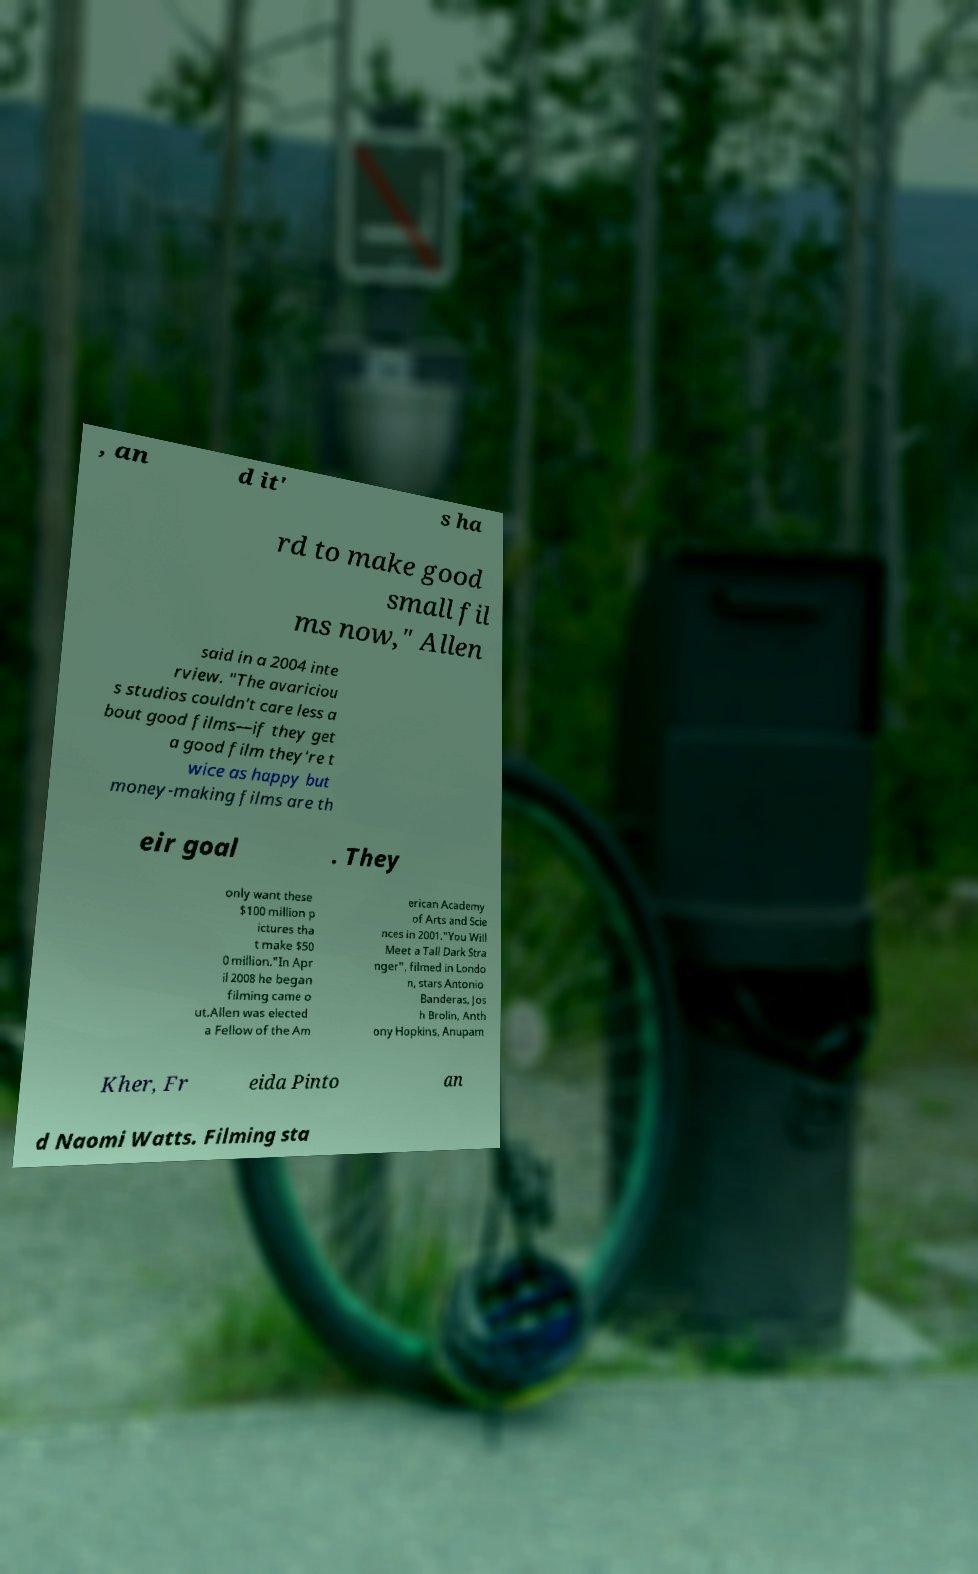Could you assist in decoding the text presented in this image and type it out clearly? , an d it' s ha rd to make good small fil ms now," Allen said in a 2004 inte rview. "The avariciou s studios couldn't care less a bout good films—if they get a good film they're t wice as happy but money-making films are th eir goal . They only want these $100 million p ictures tha t make $50 0 million."In Apr il 2008 he began filming came o ut.Allen was elected a Fellow of the Am erican Academy of Arts and Scie nces in 2001."You Will Meet a Tall Dark Stra nger", filmed in Londo n, stars Antonio Banderas, Jos h Brolin, Anth ony Hopkins, Anupam Kher, Fr eida Pinto an d Naomi Watts. Filming sta 